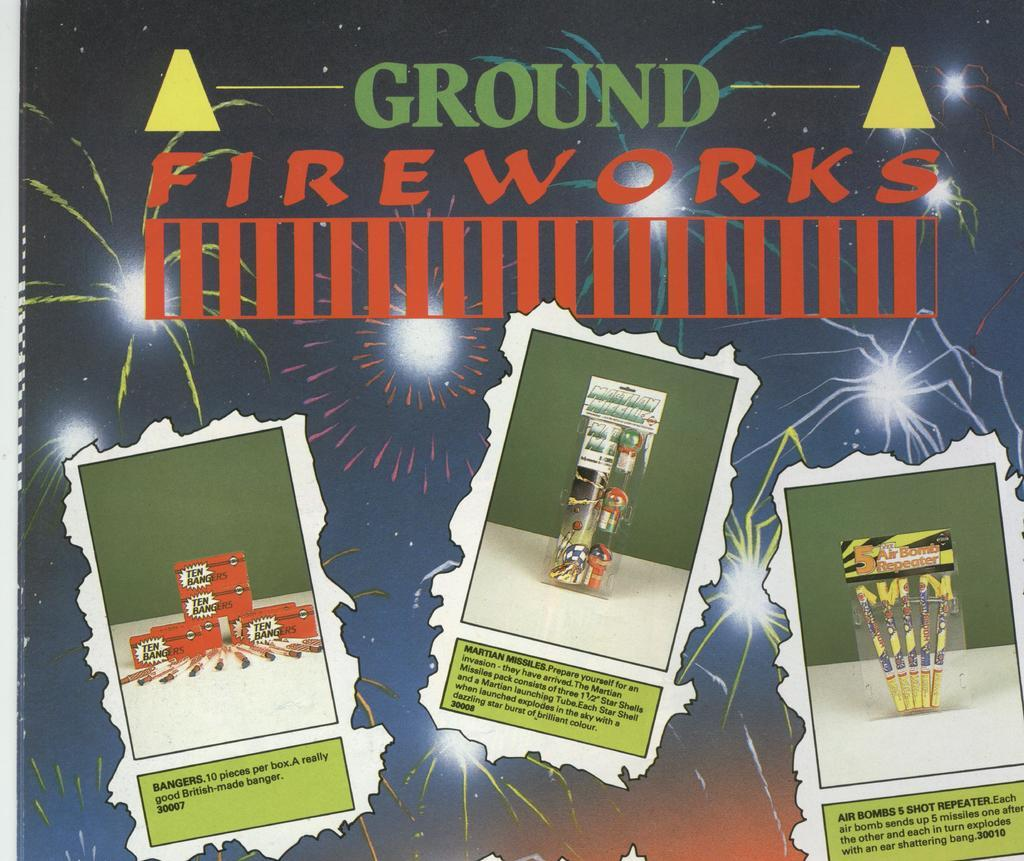<image>
Create a compact narrative representing the image presented. An advertisement for ground fireworks that shows three different sets. 